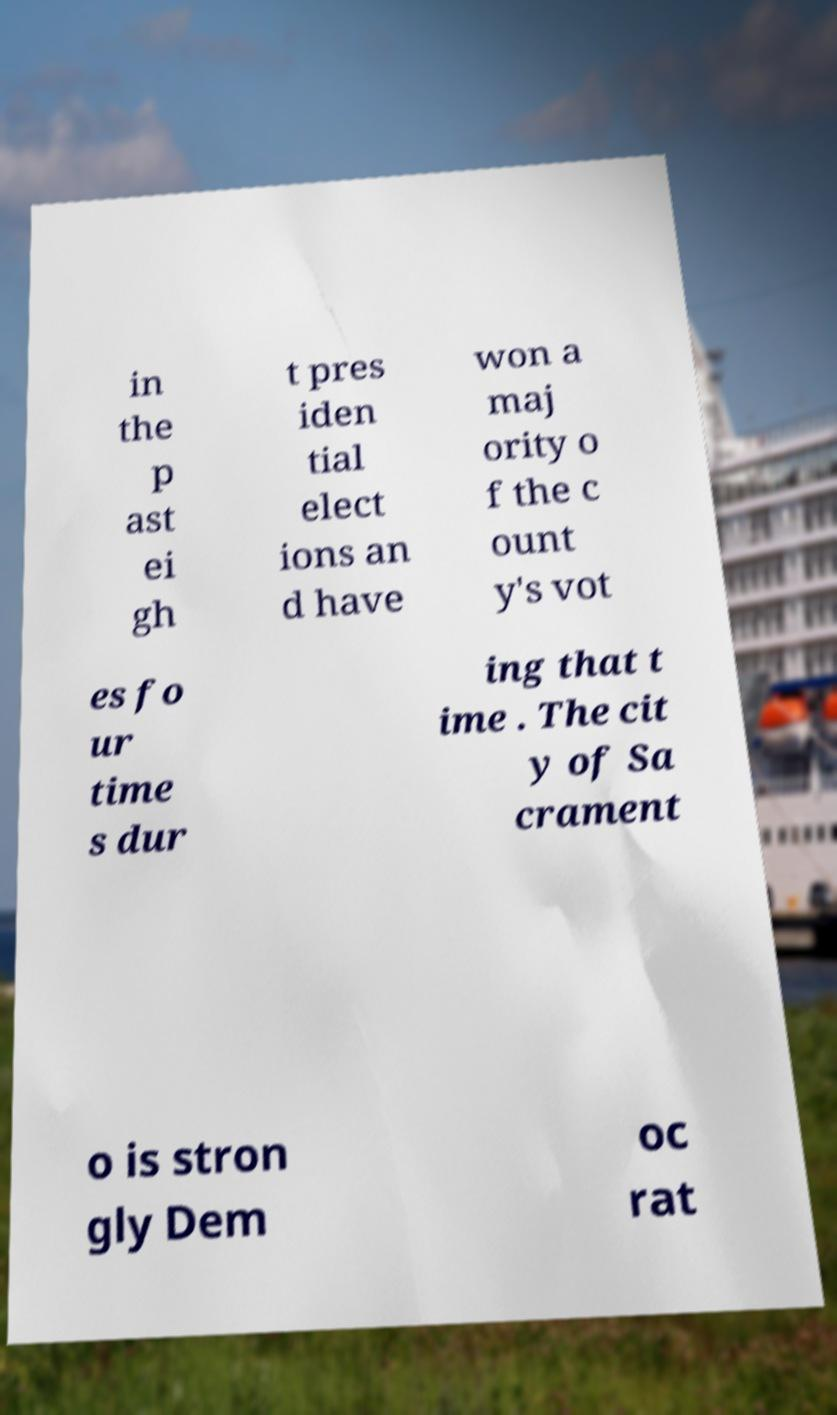Can you accurately transcribe the text from the provided image for me? in the p ast ei gh t pres iden tial elect ions an d have won a maj ority o f the c ount y's vot es fo ur time s dur ing that t ime . The cit y of Sa crament o is stron gly Dem oc rat 